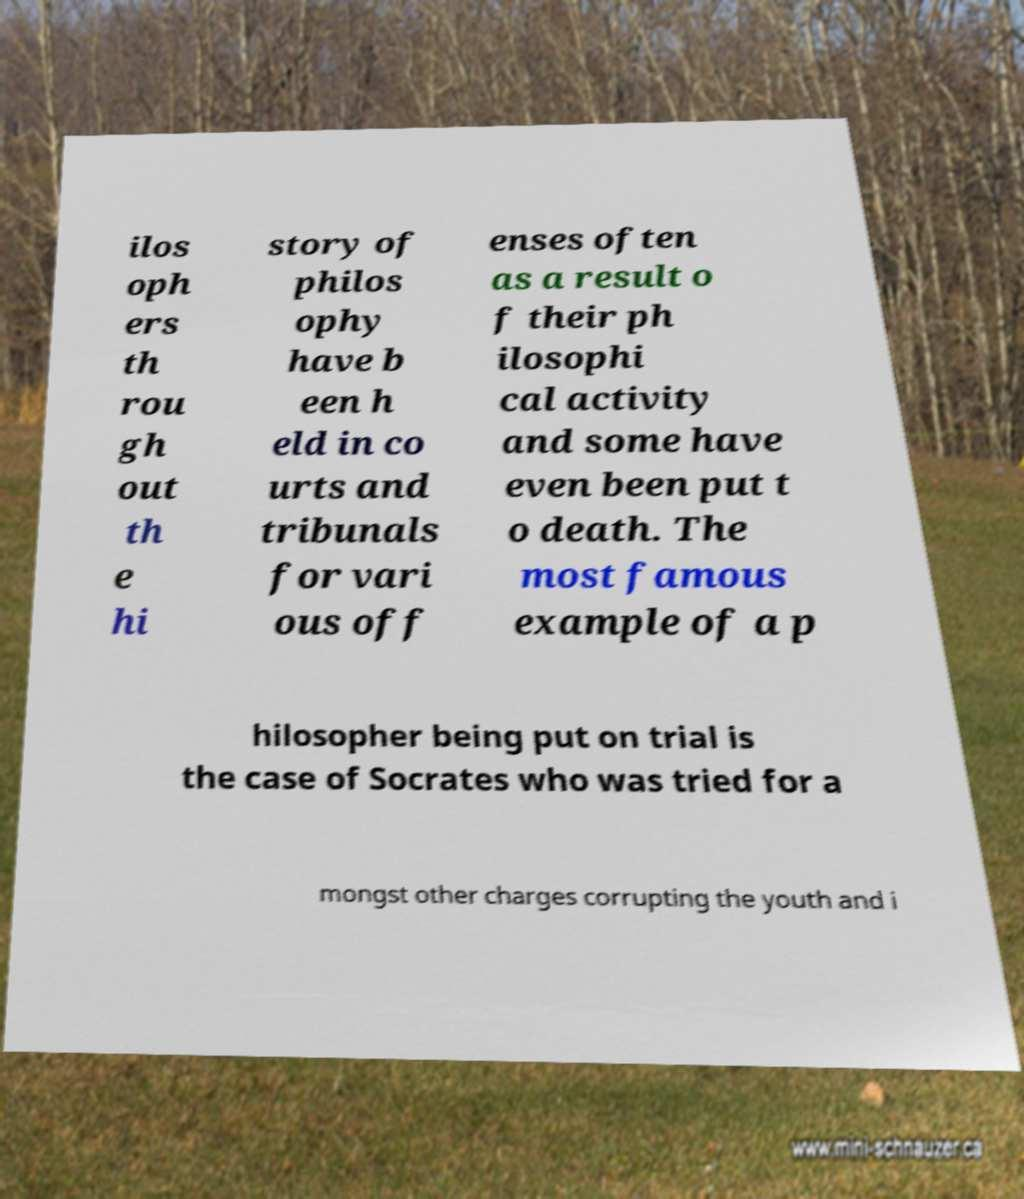What messages or text are displayed in this image? I need them in a readable, typed format. ilos oph ers th rou gh out th e hi story of philos ophy have b een h eld in co urts and tribunals for vari ous off enses often as a result o f their ph ilosophi cal activity and some have even been put t o death. The most famous example of a p hilosopher being put on trial is the case of Socrates who was tried for a mongst other charges corrupting the youth and i 